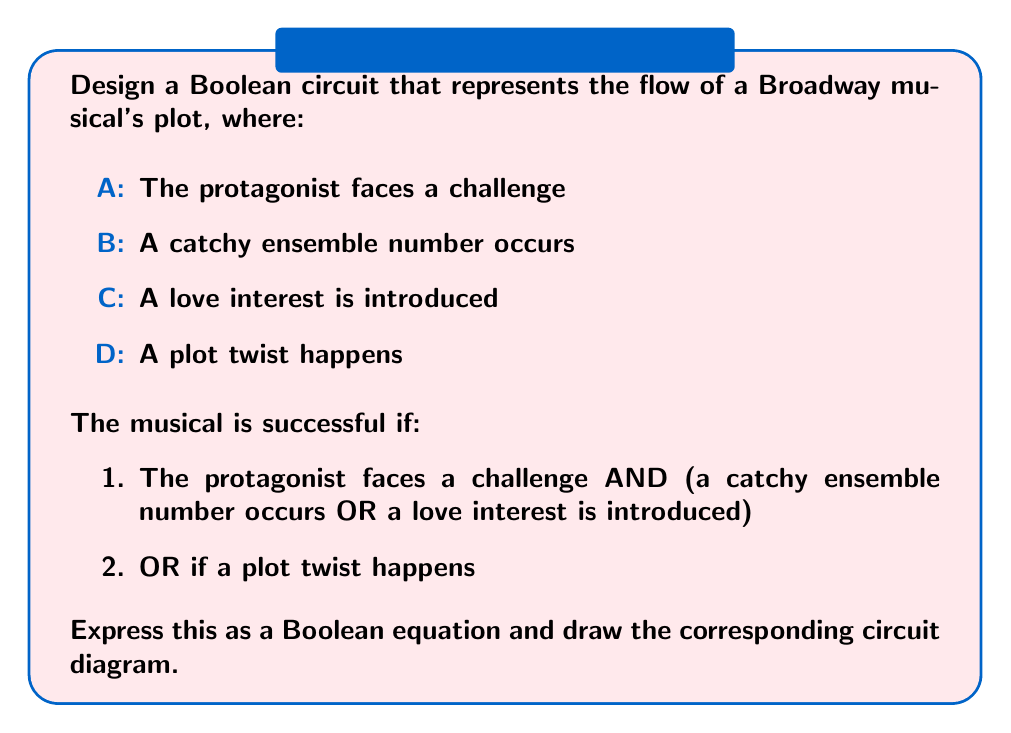Can you answer this question? Let's approach this step-by-step:

1. First, we need to translate the given conditions into a Boolean equation:

   Success = (A AND (B OR C)) OR D

2. We can break this down further:
   Let X = (B OR C)
   Then, Success = (A AND X) OR D

3. To create the circuit, we'll need:
   - An OR gate for (B OR C)
   - An AND gate for (A AND X)
   - A final OR gate for the whole expression

4. The circuit diagram would look like this:

   [asy]
   import geometry;

   // Define points
   pair A = (0,80), B = (0,60), C = (0,40), D = (0,20);
   pair OR1 = (40,50), AND = (80,65), OR2 = (120,50);
   pair out = (160,50);

   // Draw inputs
   draw(A--shift(20,0)*A, arrow=Arrow(TeXHead));
   draw(B--shift(20,0)*B, arrow=Arrow(TeXHead));
   draw(C--shift(20,0)*C, arrow=Arrow(TeXHead));
   draw(D--shift(100,0)*D, arrow=Arrow(TeXHead));

   // Draw gates
   draw(circle(OR1,20));
   label("OR", OR1);
   draw(circle(AND,20));
   label("AND", AND);
   draw(circle(OR2,20));
   label("OR", OR2);

   // Connect gates
   draw(shift(20,0)*B--OR1, arrow=Arrow(TeXHead));
   draw(shift(20,0)*C--OR1, arrow=Arrow(TeXHead));
   draw(OR1--AND, arrow=Arrow(TeXHead));
   draw(shift(20,0)*A--AND, arrow=Arrow(TeXHead));
   draw(AND--OR2, arrow=Arrow(TeXHead));
   draw(shift(100,0)*D--OR2, arrow=Arrow(TeXHead));
   draw(OR2--out, arrow=Arrow(TeXHead));

   // Label inputs and output
   label("A", A, W);
   label("B", B, W);
   label("C", C, W);
   label("D", D, W);
   label("Success", out, E);
   [/asy]

5. This circuit represents the Boolean equation: Success = (A AND (B OR C)) OR D

   It captures the essence of a successful musical plot flow as described in the question.
Answer: Success = (A AND (B OR C)) OR D 